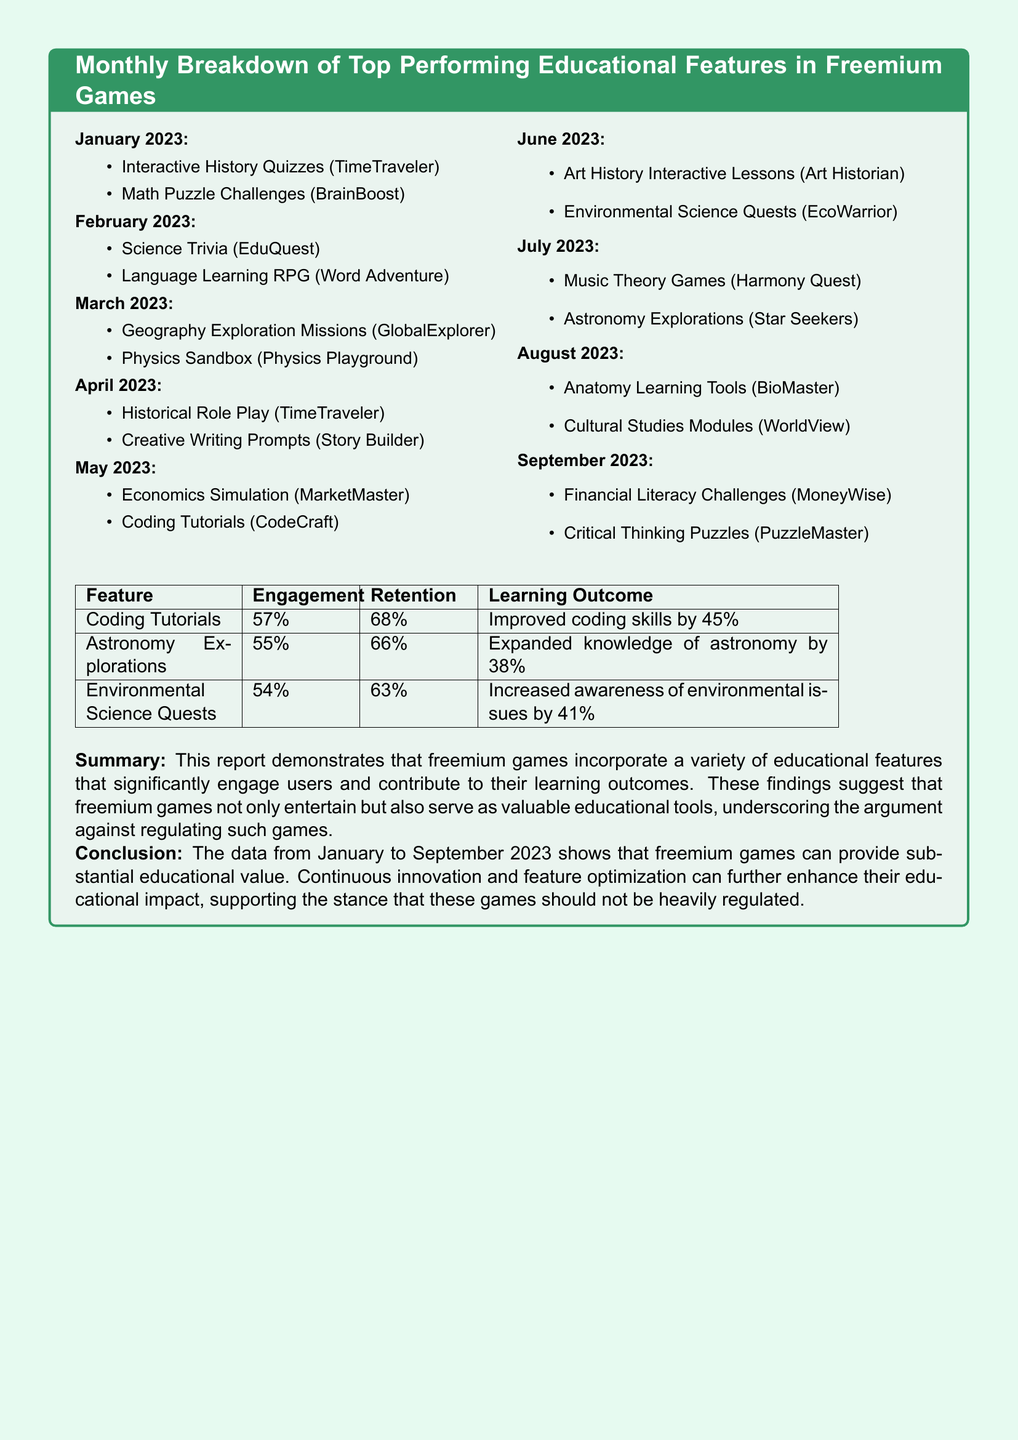What was the top feature in January 2023? The top feature in January 2023 was Interactive History Quizzes from TimeTraveler.
Answer: Interactive History Quizzes Which educational feature had the highest engagement rate? The engagement rates for various features show that Coding Tutorials had the highest engagement at 57%.
Answer: 57% What learning outcome did Astronomy Explorations achieve? The learning outcome for Astronomy Explorations is an expanded knowledge of astronomy by 38%.
Answer: Expanded knowledge of astronomy by 38% In which month was Creative Writing Prompts highlighted? Creative Writing Prompts was highlighted in April 2023 as one of the top features.
Answer: April 2023 What percentage of users retained Coding Tutorials? The retention rate for Coding Tutorials is 68%.
Answer: 68% Which educational feature appears in multiple months? Historical Role Play from TimeTraveler appears in both January and April 2023.
Answer: Historical Role Play How many features were listed in the report for September 2023? The report lists two features for September 2023, Financial Literacy Challenges and Critical Thinking Puzzles.
Answer: Two What was the general conclusion about freemium games in the report? The conclusion states that freemium games can provide substantial educational value and should not be heavily regulated.
Answer: Substantial educational value What is the main purpose of the features listed in the report? The main purpose of the features listed is to engage users and contribute to their learning outcomes.
Answer: Engage users and contribute to learning outcomes 